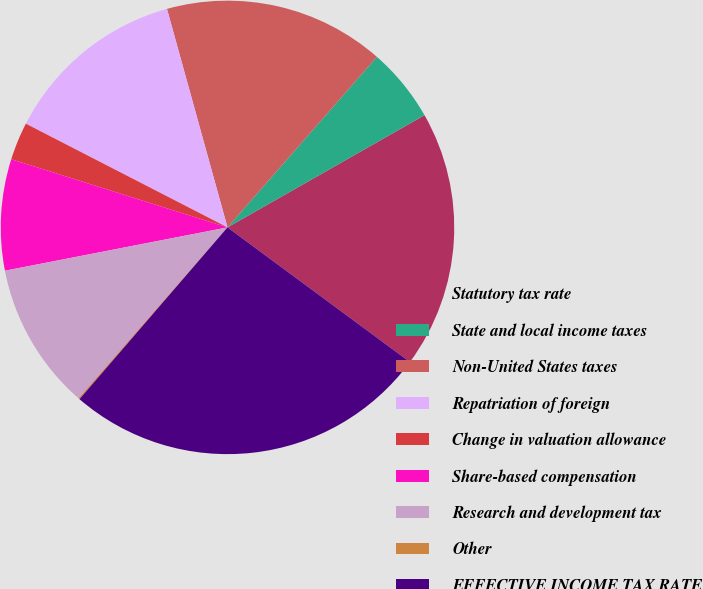Convert chart to OTSL. <chart><loc_0><loc_0><loc_500><loc_500><pie_chart><fcel>Statutory tax rate<fcel>State and local income taxes<fcel>Non-United States taxes<fcel>Repatriation of foreign<fcel>Change in valuation allowance<fcel>Share-based compensation<fcel>Research and development tax<fcel>Other<fcel>EFFECTIVE INCOME TAX RATE<nl><fcel>18.36%<fcel>5.31%<fcel>15.75%<fcel>13.14%<fcel>2.7%<fcel>7.92%<fcel>10.53%<fcel>0.09%<fcel>26.2%<nl></chart> 